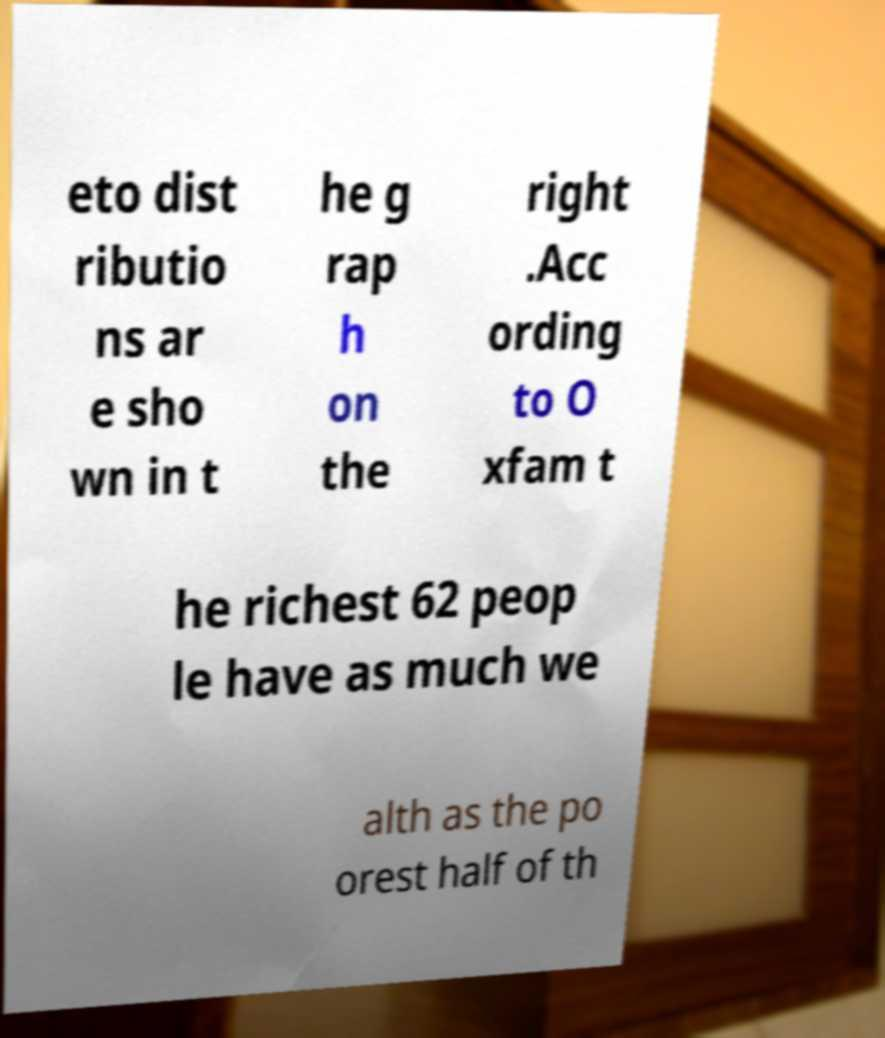Please identify and transcribe the text found in this image. eto dist ributio ns ar e sho wn in t he g rap h on the right .Acc ording to O xfam t he richest 62 peop le have as much we alth as the po orest half of th 